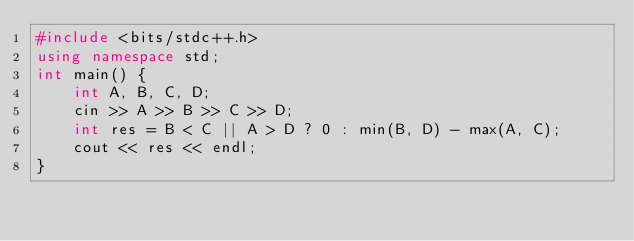<code> <loc_0><loc_0><loc_500><loc_500><_C++_>#include <bits/stdc++.h>
using namespace std;
int main() {
	int A, B, C, D;
	cin >> A >> B >> C >> D;
	int res = B < C || A > D ? 0 : min(B, D) - max(A, C);
	cout << res << endl;
}</code> 